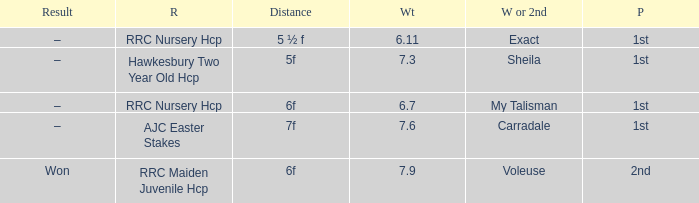What is the largest weight wth a Result of –, and a Distance of 7f? 7.6. 